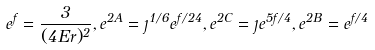<formula> <loc_0><loc_0><loc_500><loc_500>e ^ { f } = \frac { 3 } { ( 4 E r ) ^ { 2 } } , e ^ { 2 A } = \eta ^ { 1 / 6 } e ^ { f / 2 4 } , e ^ { 2 C } = \eta e ^ { 5 f / 4 } , e ^ { 2 B } = e ^ { f / 4 }</formula> 